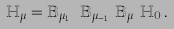Convert formula to latex. <formula><loc_0><loc_0><loc_500><loc_500>\mathbb { H } _ { \mu } = \mathbb { B } _ { \mu _ { 1 } } \cdots \mathbb { B } _ { \mu _ { n - 1 } } \mathbb { B } _ { \mu _ { n } } \mathbb { H } _ { 0 } \, .</formula> 